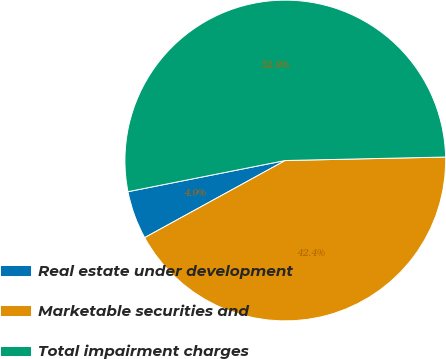Convert chart. <chart><loc_0><loc_0><loc_500><loc_500><pie_chart><fcel>Real estate under development<fcel>Marketable securities and<fcel>Total impairment charges<nl><fcel>4.87%<fcel>42.36%<fcel>52.77%<nl></chart> 